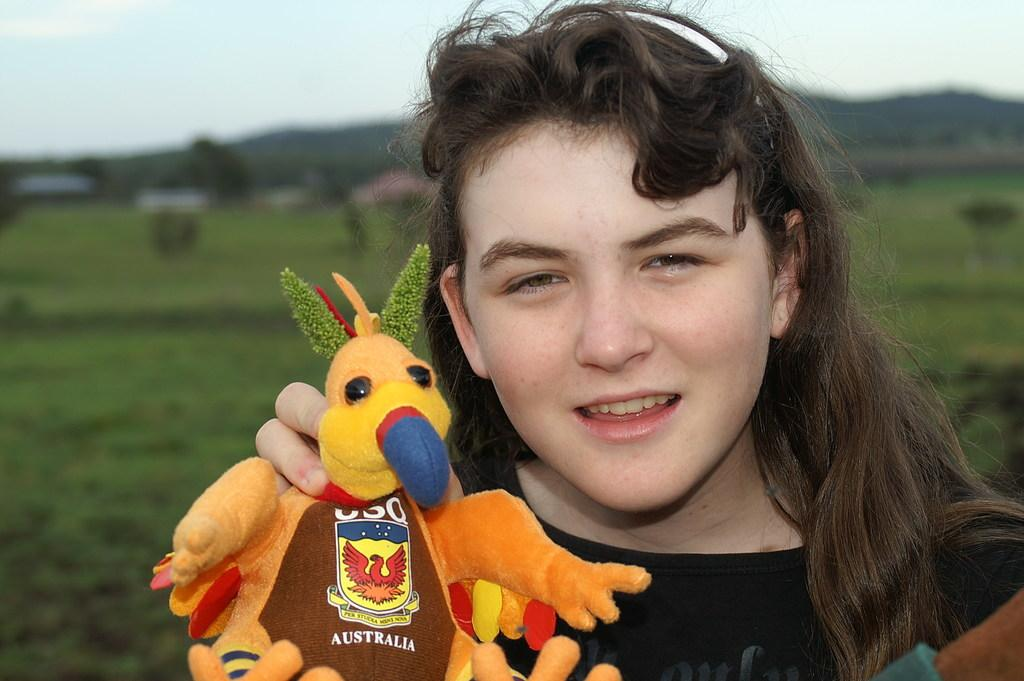Who is present in the image? There is a woman in the image. What is the woman holding in the image? The woman is holding a toy. What can be seen in the background of the image? Trees and grass are visible in the background of the image. What type of fang can be seen in the woman's mouth in the image? There is no fang visible in the woman's mouth in the image. 